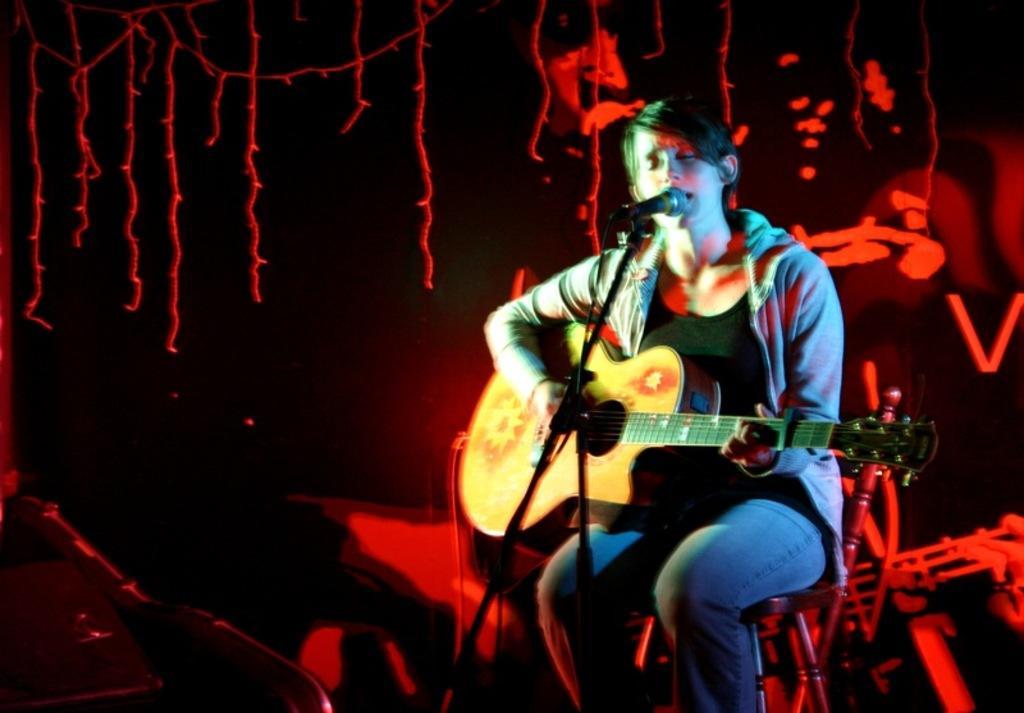Could you give a brief overview of what you see in this image? Person playing guitar and this is microphone. 